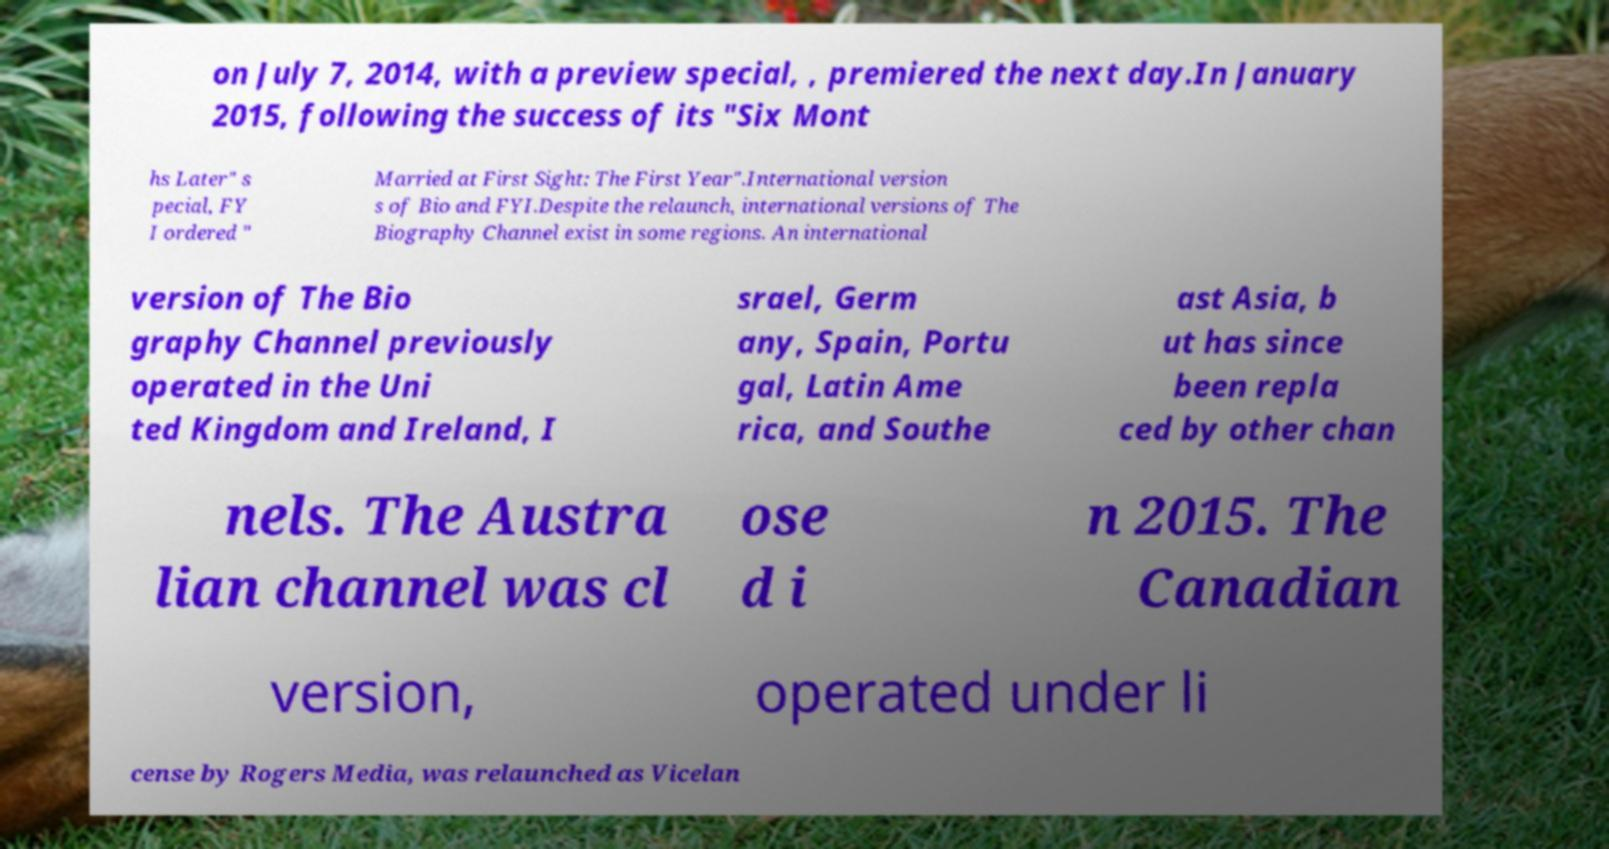What messages or text are displayed in this image? I need them in a readable, typed format. on July 7, 2014, with a preview special, , premiered the next day.In January 2015, following the success of its "Six Mont hs Later" s pecial, FY I ordered " Married at First Sight: The First Year".International version s of Bio and FYI.Despite the relaunch, international versions of The Biography Channel exist in some regions. An international version of The Bio graphy Channel previously operated in the Uni ted Kingdom and Ireland, I srael, Germ any, Spain, Portu gal, Latin Ame rica, and Southe ast Asia, b ut has since been repla ced by other chan nels. The Austra lian channel was cl ose d i n 2015. The Canadian version, operated under li cense by Rogers Media, was relaunched as Vicelan 